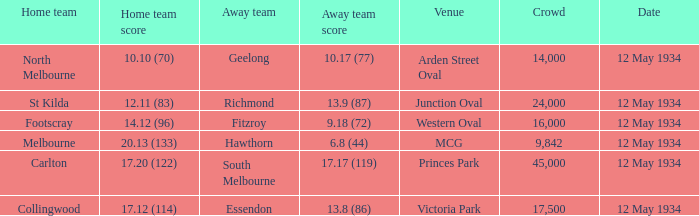Which home team played the Away team from Richmond? St Kilda. 